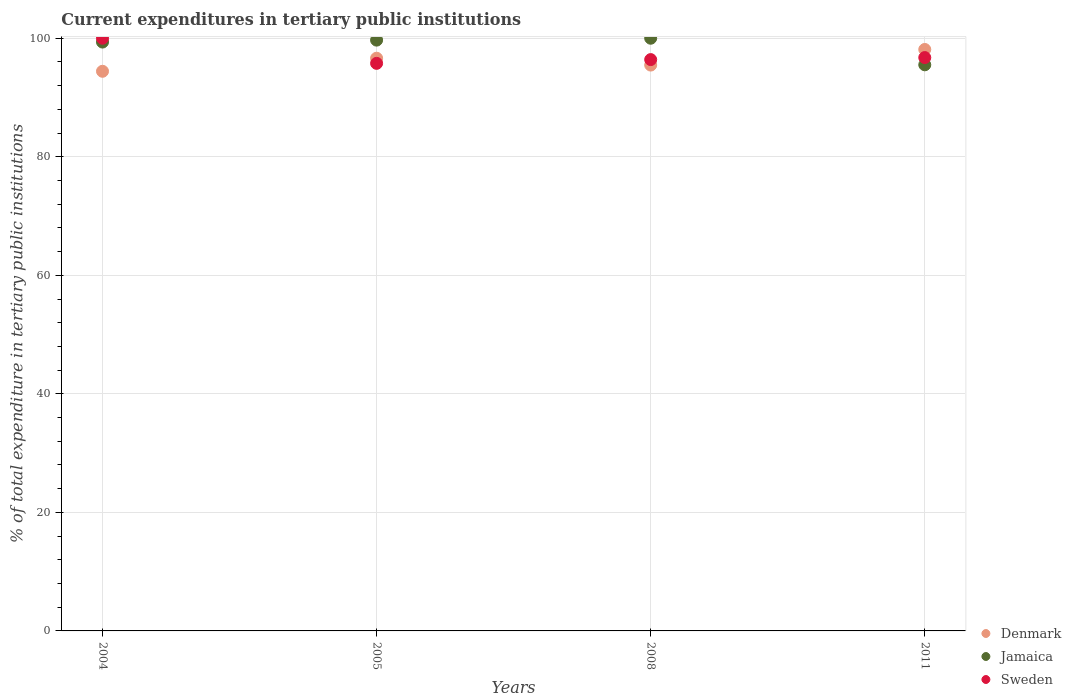What is the current expenditures in tertiary public institutions in Jamaica in 2004?
Offer a very short reply. 99.35. Across all years, what is the maximum current expenditures in tertiary public institutions in Denmark?
Make the answer very short. 98.1. Across all years, what is the minimum current expenditures in tertiary public institutions in Jamaica?
Keep it short and to the point. 95.52. In which year was the current expenditures in tertiary public institutions in Denmark maximum?
Ensure brevity in your answer.  2011. In which year was the current expenditures in tertiary public institutions in Denmark minimum?
Ensure brevity in your answer.  2004. What is the total current expenditures in tertiary public institutions in Sweden in the graph?
Your answer should be very brief. 388.89. What is the difference between the current expenditures in tertiary public institutions in Sweden in 2005 and that in 2008?
Offer a very short reply. -0.63. What is the difference between the current expenditures in tertiary public institutions in Jamaica in 2004 and the current expenditures in tertiary public institutions in Sweden in 2008?
Offer a very short reply. 2.96. What is the average current expenditures in tertiary public institutions in Sweden per year?
Give a very brief answer. 97.22. In the year 2011, what is the difference between the current expenditures in tertiary public institutions in Sweden and current expenditures in tertiary public institutions in Denmark?
Your answer should be compact. -1.37. In how many years, is the current expenditures in tertiary public institutions in Sweden greater than 32 %?
Keep it short and to the point. 4. What is the ratio of the current expenditures in tertiary public institutions in Denmark in 2005 to that in 2008?
Provide a succinct answer. 1.01. Is the current expenditures in tertiary public institutions in Denmark in 2005 less than that in 2008?
Your answer should be compact. No. Is the difference between the current expenditures in tertiary public institutions in Sweden in 2004 and 2008 greater than the difference between the current expenditures in tertiary public institutions in Denmark in 2004 and 2008?
Offer a very short reply. Yes. What is the difference between the highest and the second highest current expenditures in tertiary public institutions in Sweden?
Provide a short and direct response. 3.26. What is the difference between the highest and the lowest current expenditures in tertiary public institutions in Jamaica?
Your answer should be very brief. 4.48. In how many years, is the current expenditures in tertiary public institutions in Jamaica greater than the average current expenditures in tertiary public institutions in Jamaica taken over all years?
Give a very brief answer. 3. Is it the case that in every year, the sum of the current expenditures in tertiary public institutions in Jamaica and current expenditures in tertiary public institutions in Sweden  is greater than the current expenditures in tertiary public institutions in Denmark?
Give a very brief answer. Yes. Is the current expenditures in tertiary public institutions in Denmark strictly less than the current expenditures in tertiary public institutions in Sweden over the years?
Give a very brief answer. No. How many dotlines are there?
Offer a very short reply. 3. How many years are there in the graph?
Give a very brief answer. 4. Are the values on the major ticks of Y-axis written in scientific E-notation?
Your response must be concise. No. How are the legend labels stacked?
Provide a short and direct response. Vertical. What is the title of the graph?
Your answer should be compact. Current expenditures in tertiary public institutions. Does "Puerto Rico" appear as one of the legend labels in the graph?
Your response must be concise. No. What is the label or title of the X-axis?
Make the answer very short. Years. What is the label or title of the Y-axis?
Your answer should be very brief. % of total expenditure in tertiary public institutions. What is the % of total expenditure in tertiary public institutions of Denmark in 2004?
Offer a terse response. 94.42. What is the % of total expenditure in tertiary public institutions in Jamaica in 2004?
Ensure brevity in your answer.  99.35. What is the % of total expenditure in tertiary public institutions in Sweden in 2004?
Your answer should be compact. 100. What is the % of total expenditure in tertiary public institutions of Denmark in 2005?
Offer a terse response. 96.63. What is the % of total expenditure in tertiary public institutions in Jamaica in 2005?
Provide a succinct answer. 99.68. What is the % of total expenditure in tertiary public institutions in Sweden in 2005?
Offer a very short reply. 95.76. What is the % of total expenditure in tertiary public institutions of Denmark in 2008?
Keep it short and to the point. 95.47. What is the % of total expenditure in tertiary public institutions of Jamaica in 2008?
Your answer should be very brief. 100. What is the % of total expenditure in tertiary public institutions in Sweden in 2008?
Your response must be concise. 96.39. What is the % of total expenditure in tertiary public institutions of Denmark in 2011?
Ensure brevity in your answer.  98.1. What is the % of total expenditure in tertiary public institutions of Jamaica in 2011?
Provide a succinct answer. 95.52. What is the % of total expenditure in tertiary public institutions of Sweden in 2011?
Keep it short and to the point. 96.74. Across all years, what is the maximum % of total expenditure in tertiary public institutions of Denmark?
Make the answer very short. 98.1. Across all years, what is the maximum % of total expenditure in tertiary public institutions in Jamaica?
Give a very brief answer. 100. Across all years, what is the maximum % of total expenditure in tertiary public institutions in Sweden?
Give a very brief answer. 100. Across all years, what is the minimum % of total expenditure in tertiary public institutions in Denmark?
Offer a terse response. 94.42. Across all years, what is the minimum % of total expenditure in tertiary public institutions in Jamaica?
Offer a terse response. 95.52. Across all years, what is the minimum % of total expenditure in tertiary public institutions of Sweden?
Your answer should be very brief. 95.76. What is the total % of total expenditure in tertiary public institutions in Denmark in the graph?
Keep it short and to the point. 384.63. What is the total % of total expenditure in tertiary public institutions of Jamaica in the graph?
Keep it short and to the point. 394.55. What is the total % of total expenditure in tertiary public institutions of Sweden in the graph?
Give a very brief answer. 388.89. What is the difference between the % of total expenditure in tertiary public institutions in Denmark in 2004 and that in 2005?
Provide a short and direct response. -2.2. What is the difference between the % of total expenditure in tertiary public institutions in Jamaica in 2004 and that in 2005?
Your answer should be compact. -0.33. What is the difference between the % of total expenditure in tertiary public institutions of Sweden in 2004 and that in 2005?
Offer a very short reply. 4.24. What is the difference between the % of total expenditure in tertiary public institutions in Denmark in 2004 and that in 2008?
Provide a short and direct response. -1.05. What is the difference between the % of total expenditure in tertiary public institutions in Jamaica in 2004 and that in 2008?
Make the answer very short. -0.65. What is the difference between the % of total expenditure in tertiary public institutions in Sweden in 2004 and that in 2008?
Keep it short and to the point. 3.6. What is the difference between the % of total expenditure in tertiary public institutions in Denmark in 2004 and that in 2011?
Your answer should be compact. -3.68. What is the difference between the % of total expenditure in tertiary public institutions of Jamaica in 2004 and that in 2011?
Ensure brevity in your answer.  3.84. What is the difference between the % of total expenditure in tertiary public institutions in Sweden in 2004 and that in 2011?
Your response must be concise. 3.26. What is the difference between the % of total expenditure in tertiary public institutions in Denmark in 2005 and that in 2008?
Provide a short and direct response. 1.16. What is the difference between the % of total expenditure in tertiary public institutions in Jamaica in 2005 and that in 2008?
Give a very brief answer. -0.32. What is the difference between the % of total expenditure in tertiary public institutions of Sweden in 2005 and that in 2008?
Provide a succinct answer. -0.63. What is the difference between the % of total expenditure in tertiary public institutions of Denmark in 2005 and that in 2011?
Your response must be concise. -1.48. What is the difference between the % of total expenditure in tertiary public institutions of Jamaica in 2005 and that in 2011?
Ensure brevity in your answer.  4.16. What is the difference between the % of total expenditure in tertiary public institutions in Sweden in 2005 and that in 2011?
Your response must be concise. -0.97. What is the difference between the % of total expenditure in tertiary public institutions of Denmark in 2008 and that in 2011?
Provide a succinct answer. -2.63. What is the difference between the % of total expenditure in tertiary public institutions in Jamaica in 2008 and that in 2011?
Ensure brevity in your answer.  4.48. What is the difference between the % of total expenditure in tertiary public institutions of Sweden in 2008 and that in 2011?
Offer a very short reply. -0.34. What is the difference between the % of total expenditure in tertiary public institutions in Denmark in 2004 and the % of total expenditure in tertiary public institutions in Jamaica in 2005?
Offer a very short reply. -5.26. What is the difference between the % of total expenditure in tertiary public institutions of Denmark in 2004 and the % of total expenditure in tertiary public institutions of Sweden in 2005?
Your response must be concise. -1.34. What is the difference between the % of total expenditure in tertiary public institutions of Jamaica in 2004 and the % of total expenditure in tertiary public institutions of Sweden in 2005?
Provide a short and direct response. 3.59. What is the difference between the % of total expenditure in tertiary public institutions of Denmark in 2004 and the % of total expenditure in tertiary public institutions of Jamaica in 2008?
Ensure brevity in your answer.  -5.58. What is the difference between the % of total expenditure in tertiary public institutions of Denmark in 2004 and the % of total expenditure in tertiary public institutions of Sweden in 2008?
Offer a terse response. -1.97. What is the difference between the % of total expenditure in tertiary public institutions in Jamaica in 2004 and the % of total expenditure in tertiary public institutions in Sweden in 2008?
Ensure brevity in your answer.  2.96. What is the difference between the % of total expenditure in tertiary public institutions in Denmark in 2004 and the % of total expenditure in tertiary public institutions in Jamaica in 2011?
Your answer should be very brief. -1.09. What is the difference between the % of total expenditure in tertiary public institutions in Denmark in 2004 and the % of total expenditure in tertiary public institutions in Sweden in 2011?
Offer a terse response. -2.31. What is the difference between the % of total expenditure in tertiary public institutions in Jamaica in 2004 and the % of total expenditure in tertiary public institutions in Sweden in 2011?
Provide a short and direct response. 2.62. What is the difference between the % of total expenditure in tertiary public institutions in Denmark in 2005 and the % of total expenditure in tertiary public institutions in Jamaica in 2008?
Provide a short and direct response. -3.37. What is the difference between the % of total expenditure in tertiary public institutions of Denmark in 2005 and the % of total expenditure in tertiary public institutions of Sweden in 2008?
Your response must be concise. 0.23. What is the difference between the % of total expenditure in tertiary public institutions of Jamaica in 2005 and the % of total expenditure in tertiary public institutions of Sweden in 2008?
Your response must be concise. 3.29. What is the difference between the % of total expenditure in tertiary public institutions of Denmark in 2005 and the % of total expenditure in tertiary public institutions of Jamaica in 2011?
Your answer should be compact. 1.11. What is the difference between the % of total expenditure in tertiary public institutions in Denmark in 2005 and the % of total expenditure in tertiary public institutions in Sweden in 2011?
Provide a succinct answer. -0.11. What is the difference between the % of total expenditure in tertiary public institutions in Jamaica in 2005 and the % of total expenditure in tertiary public institutions in Sweden in 2011?
Ensure brevity in your answer.  2.95. What is the difference between the % of total expenditure in tertiary public institutions of Denmark in 2008 and the % of total expenditure in tertiary public institutions of Jamaica in 2011?
Your answer should be very brief. -0.05. What is the difference between the % of total expenditure in tertiary public institutions in Denmark in 2008 and the % of total expenditure in tertiary public institutions in Sweden in 2011?
Provide a succinct answer. -1.26. What is the difference between the % of total expenditure in tertiary public institutions of Jamaica in 2008 and the % of total expenditure in tertiary public institutions of Sweden in 2011?
Offer a very short reply. 3.26. What is the average % of total expenditure in tertiary public institutions of Denmark per year?
Your answer should be compact. 96.16. What is the average % of total expenditure in tertiary public institutions of Jamaica per year?
Your response must be concise. 98.64. What is the average % of total expenditure in tertiary public institutions in Sweden per year?
Provide a succinct answer. 97.22. In the year 2004, what is the difference between the % of total expenditure in tertiary public institutions of Denmark and % of total expenditure in tertiary public institutions of Jamaica?
Your answer should be compact. -4.93. In the year 2004, what is the difference between the % of total expenditure in tertiary public institutions of Denmark and % of total expenditure in tertiary public institutions of Sweden?
Your answer should be compact. -5.58. In the year 2004, what is the difference between the % of total expenditure in tertiary public institutions of Jamaica and % of total expenditure in tertiary public institutions of Sweden?
Make the answer very short. -0.65. In the year 2005, what is the difference between the % of total expenditure in tertiary public institutions in Denmark and % of total expenditure in tertiary public institutions in Jamaica?
Your answer should be very brief. -3.05. In the year 2005, what is the difference between the % of total expenditure in tertiary public institutions in Denmark and % of total expenditure in tertiary public institutions in Sweden?
Make the answer very short. 0.86. In the year 2005, what is the difference between the % of total expenditure in tertiary public institutions in Jamaica and % of total expenditure in tertiary public institutions in Sweden?
Your answer should be compact. 3.92. In the year 2008, what is the difference between the % of total expenditure in tertiary public institutions of Denmark and % of total expenditure in tertiary public institutions of Jamaica?
Ensure brevity in your answer.  -4.53. In the year 2008, what is the difference between the % of total expenditure in tertiary public institutions of Denmark and % of total expenditure in tertiary public institutions of Sweden?
Offer a very short reply. -0.92. In the year 2008, what is the difference between the % of total expenditure in tertiary public institutions of Jamaica and % of total expenditure in tertiary public institutions of Sweden?
Provide a short and direct response. 3.6. In the year 2011, what is the difference between the % of total expenditure in tertiary public institutions of Denmark and % of total expenditure in tertiary public institutions of Jamaica?
Your response must be concise. 2.59. In the year 2011, what is the difference between the % of total expenditure in tertiary public institutions in Denmark and % of total expenditure in tertiary public institutions in Sweden?
Offer a very short reply. 1.37. In the year 2011, what is the difference between the % of total expenditure in tertiary public institutions of Jamaica and % of total expenditure in tertiary public institutions of Sweden?
Make the answer very short. -1.22. What is the ratio of the % of total expenditure in tertiary public institutions in Denmark in 2004 to that in 2005?
Your response must be concise. 0.98. What is the ratio of the % of total expenditure in tertiary public institutions of Jamaica in 2004 to that in 2005?
Ensure brevity in your answer.  1. What is the ratio of the % of total expenditure in tertiary public institutions in Sweden in 2004 to that in 2005?
Offer a very short reply. 1.04. What is the ratio of the % of total expenditure in tertiary public institutions in Jamaica in 2004 to that in 2008?
Offer a very short reply. 0.99. What is the ratio of the % of total expenditure in tertiary public institutions in Sweden in 2004 to that in 2008?
Make the answer very short. 1.04. What is the ratio of the % of total expenditure in tertiary public institutions of Denmark in 2004 to that in 2011?
Your answer should be very brief. 0.96. What is the ratio of the % of total expenditure in tertiary public institutions of Jamaica in 2004 to that in 2011?
Offer a very short reply. 1.04. What is the ratio of the % of total expenditure in tertiary public institutions of Sweden in 2004 to that in 2011?
Your answer should be very brief. 1.03. What is the ratio of the % of total expenditure in tertiary public institutions in Denmark in 2005 to that in 2008?
Make the answer very short. 1.01. What is the ratio of the % of total expenditure in tertiary public institutions in Jamaica in 2005 to that in 2008?
Give a very brief answer. 1. What is the ratio of the % of total expenditure in tertiary public institutions in Sweden in 2005 to that in 2008?
Offer a very short reply. 0.99. What is the ratio of the % of total expenditure in tertiary public institutions in Denmark in 2005 to that in 2011?
Provide a short and direct response. 0.98. What is the ratio of the % of total expenditure in tertiary public institutions in Jamaica in 2005 to that in 2011?
Keep it short and to the point. 1.04. What is the ratio of the % of total expenditure in tertiary public institutions in Sweden in 2005 to that in 2011?
Provide a short and direct response. 0.99. What is the ratio of the % of total expenditure in tertiary public institutions in Denmark in 2008 to that in 2011?
Provide a succinct answer. 0.97. What is the ratio of the % of total expenditure in tertiary public institutions of Jamaica in 2008 to that in 2011?
Give a very brief answer. 1.05. What is the ratio of the % of total expenditure in tertiary public institutions of Sweden in 2008 to that in 2011?
Give a very brief answer. 1. What is the difference between the highest and the second highest % of total expenditure in tertiary public institutions of Denmark?
Your answer should be compact. 1.48. What is the difference between the highest and the second highest % of total expenditure in tertiary public institutions in Jamaica?
Provide a short and direct response. 0.32. What is the difference between the highest and the second highest % of total expenditure in tertiary public institutions of Sweden?
Give a very brief answer. 3.26. What is the difference between the highest and the lowest % of total expenditure in tertiary public institutions in Denmark?
Offer a terse response. 3.68. What is the difference between the highest and the lowest % of total expenditure in tertiary public institutions in Jamaica?
Provide a short and direct response. 4.48. What is the difference between the highest and the lowest % of total expenditure in tertiary public institutions in Sweden?
Make the answer very short. 4.24. 